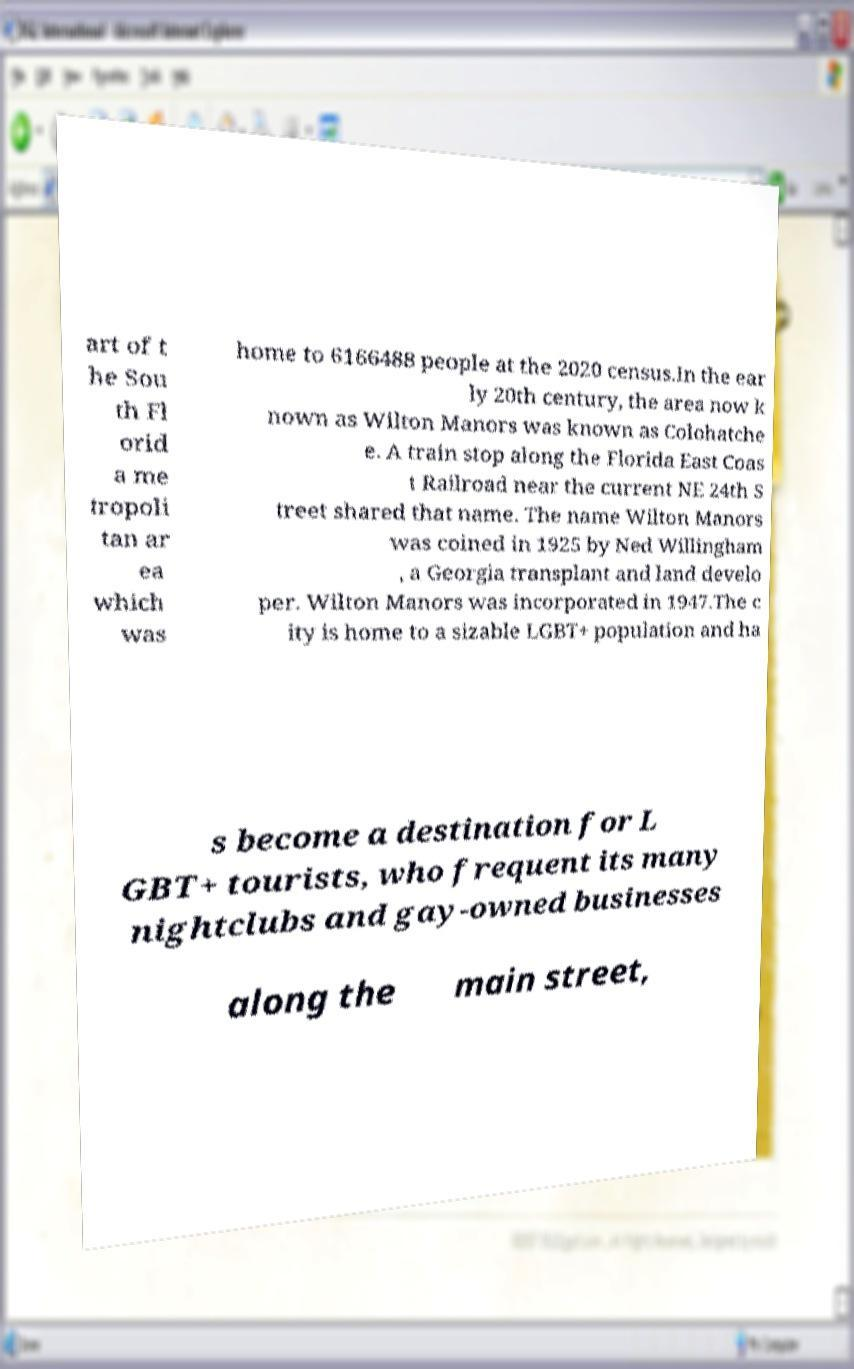Could you extract and type out the text from this image? art of t he Sou th Fl orid a me tropoli tan ar ea which was home to 6166488 people at the 2020 census.In the ear ly 20th century, the area now k nown as Wilton Manors was known as Colohatche e. A train stop along the Florida East Coas t Railroad near the current NE 24th S treet shared that name. The name Wilton Manors was coined in 1925 by Ned Willingham , a Georgia transplant and land develo per. Wilton Manors was incorporated in 1947.The c ity is home to a sizable LGBT+ population and ha s become a destination for L GBT+ tourists, who frequent its many nightclubs and gay-owned businesses along the main street, 